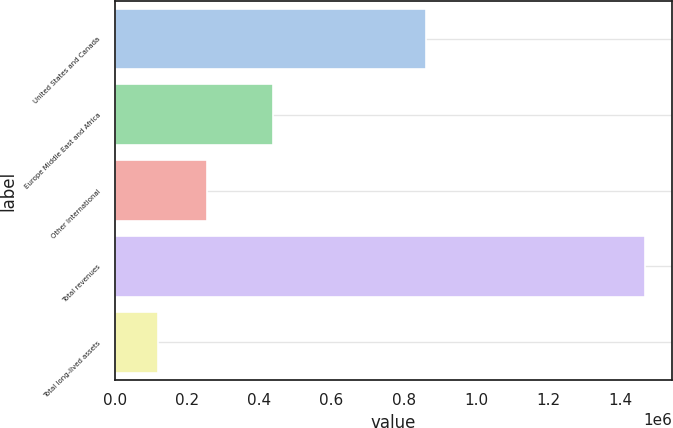Convert chart to OTSL. <chart><loc_0><loc_0><loc_500><loc_500><bar_chart><fcel>United States and Canada<fcel>Europe Middle East and Africa<fcel>Other International<fcel>Total revenues<fcel>Total long-lived assets<nl><fcel>861481<fcel>437194<fcel>254518<fcel>1.46859e+06<fcel>119621<nl></chart> 